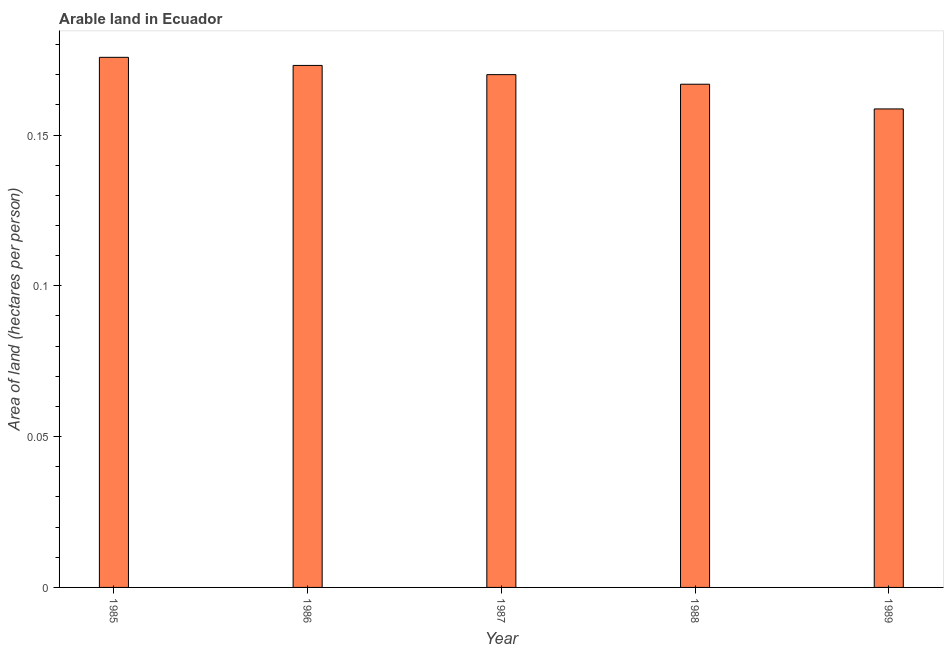What is the title of the graph?
Your answer should be very brief. Arable land in Ecuador. What is the label or title of the Y-axis?
Keep it short and to the point. Area of land (hectares per person). What is the area of arable land in 1985?
Provide a succinct answer. 0.18. Across all years, what is the maximum area of arable land?
Provide a short and direct response. 0.18. Across all years, what is the minimum area of arable land?
Offer a very short reply. 0.16. In which year was the area of arable land minimum?
Your answer should be compact. 1989. What is the sum of the area of arable land?
Provide a succinct answer. 0.84. What is the difference between the area of arable land in 1986 and 1987?
Offer a very short reply. 0. What is the average area of arable land per year?
Provide a short and direct response. 0.17. What is the median area of arable land?
Offer a terse response. 0.17. In how many years, is the area of arable land greater than 0.16 hectares per person?
Give a very brief answer. 4. Do a majority of the years between 1986 and 1987 (inclusive) have area of arable land greater than 0.12 hectares per person?
Give a very brief answer. Yes. What is the ratio of the area of arable land in 1985 to that in 1987?
Provide a short and direct response. 1.03. Is the difference between the area of arable land in 1988 and 1989 greater than the difference between any two years?
Provide a short and direct response. No. What is the difference between the highest and the second highest area of arable land?
Provide a short and direct response. 0. Is the sum of the area of arable land in 1988 and 1989 greater than the maximum area of arable land across all years?
Provide a succinct answer. Yes. What is the difference between the highest and the lowest area of arable land?
Offer a terse response. 0.02. In how many years, is the area of arable land greater than the average area of arable land taken over all years?
Provide a short and direct response. 3. How many bars are there?
Give a very brief answer. 5. Are all the bars in the graph horizontal?
Make the answer very short. No. What is the difference between two consecutive major ticks on the Y-axis?
Provide a short and direct response. 0.05. Are the values on the major ticks of Y-axis written in scientific E-notation?
Provide a succinct answer. No. What is the Area of land (hectares per person) in 1985?
Provide a short and direct response. 0.18. What is the Area of land (hectares per person) in 1986?
Give a very brief answer. 0.17. What is the Area of land (hectares per person) in 1987?
Your answer should be very brief. 0.17. What is the Area of land (hectares per person) in 1988?
Offer a very short reply. 0.17. What is the Area of land (hectares per person) in 1989?
Give a very brief answer. 0.16. What is the difference between the Area of land (hectares per person) in 1985 and 1986?
Offer a terse response. 0. What is the difference between the Area of land (hectares per person) in 1985 and 1987?
Provide a short and direct response. 0.01. What is the difference between the Area of land (hectares per person) in 1985 and 1988?
Your answer should be very brief. 0.01. What is the difference between the Area of land (hectares per person) in 1985 and 1989?
Your answer should be very brief. 0.02. What is the difference between the Area of land (hectares per person) in 1986 and 1987?
Give a very brief answer. 0. What is the difference between the Area of land (hectares per person) in 1986 and 1988?
Ensure brevity in your answer.  0.01. What is the difference between the Area of land (hectares per person) in 1986 and 1989?
Ensure brevity in your answer.  0.01. What is the difference between the Area of land (hectares per person) in 1987 and 1988?
Offer a terse response. 0. What is the difference between the Area of land (hectares per person) in 1987 and 1989?
Your response must be concise. 0.01. What is the difference between the Area of land (hectares per person) in 1988 and 1989?
Your answer should be very brief. 0.01. What is the ratio of the Area of land (hectares per person) in 1985 to that in 1986?
Your response must be concise. 1.02. What is the ratio of the Area of land (hectares per person) in 1985 to that in 1987?
Your answer should be compact. 1.03. What is the ratio of the Area of land (hectares per person) in 1985 to that in 1988?
Ensure brevity in your answer.  1.05. What is the ratio of the Area of land (hectares per person) in 1985 to that in 1989?
Provide a short and direct response. 1.11. What is the ratio of the Area of land (hectares per person) in 1986 to that in 1987?
Ensure brevity in your answer.  1.02. What is the ratio of the Area of land (hectares per person) in 1986 to that in 1989?
Provide a succinct answer. 1.09. What is the ratio of the Area of land (hectares per person) in 1987 to that in 1989?
Offer a terse response. 1.07. What is the ratio of the Area of land (hectares per person) in 1988 to that in 1989?
Provide a succinct answer. 1.05. 